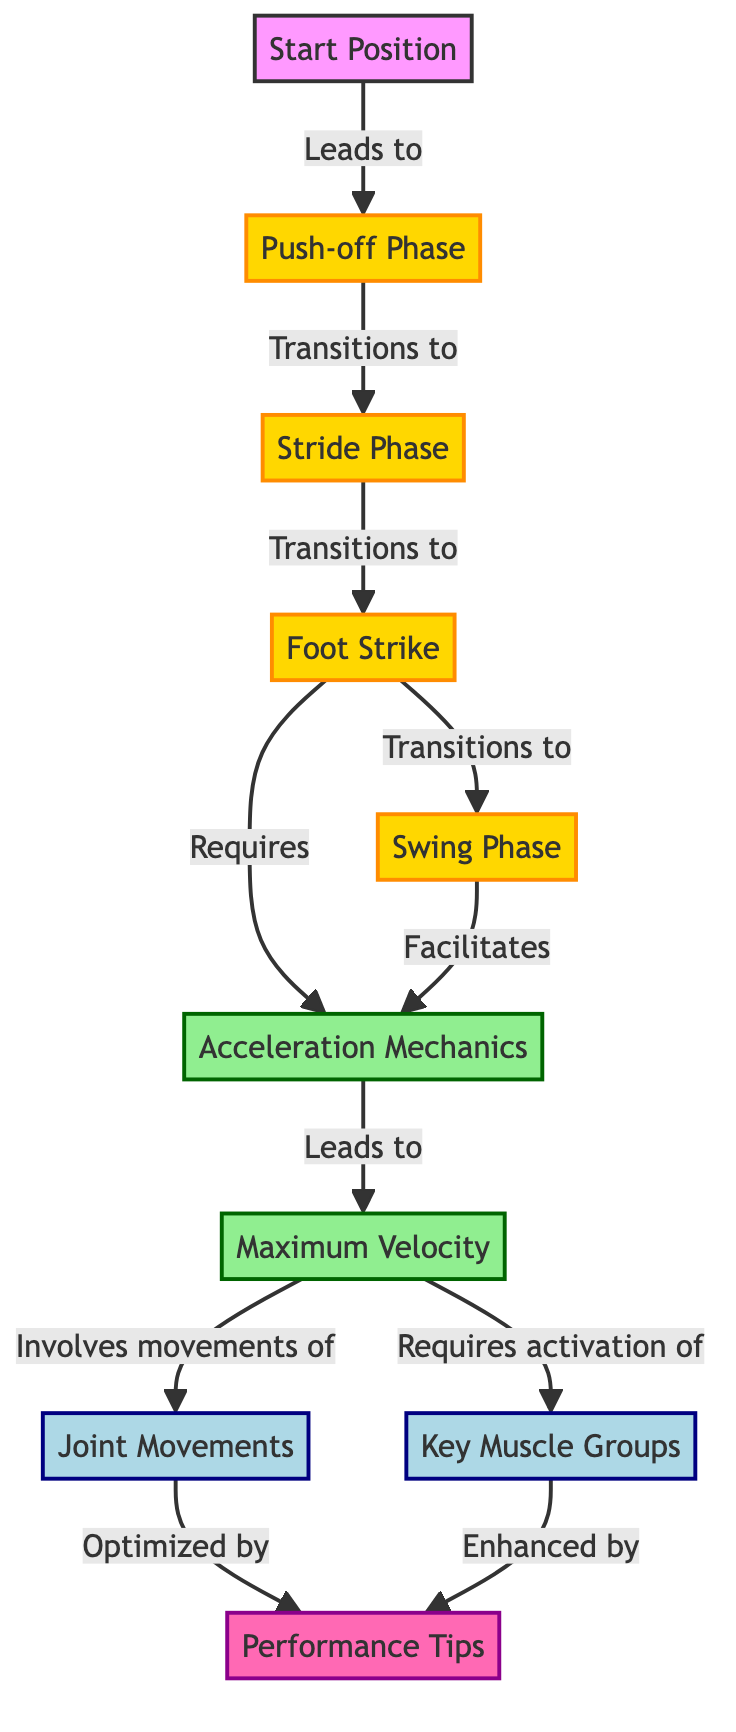What is the first phase of sprinting? The diagram starts with a node labeled "Start Position," which directly leads to the "Push-off Phase." Therefore, the first phase is identified as "Push-off Phase."
Answer: Push-off Phase What comes after the "Stride Phase"? According to the flow in the diagram, following the "Stride Phase" is the "Foot Strike." So, to determine what comes next, we refer to the connection between these two nodes, which shows the direct transition from "Stride Phase" to "Foot Strike."
Answer: Foot Strike How many phases are identified in the diagram? By counting the nodes labeled with "Phase," we identify four phases in total: "Push-off Phase," "Stride Phase," "Foot Strike," and "Swing Phase." Thus, the total number of phases is determined to be four.
Answer: 4 What mechanics does the "Foot Strike" require? The diagram specifies that the "Foot Strike" phase requires "Acceleration Mechanics." Thus, this connection between "Foot Strike" and "Acceleration Mechanics" clearly indicates the requirement.
Answer: Acceleration Mechanics How does "Swing Phase" contribute to speed? The diagram indicates that the "Swing Phase" facilitates "Acceleration," showing a direct connection. Therefore, the "Swing Phase" plays a significant role in enhancing the speed of sprinting by aiding this acceleration.
Answer: Acceleration Which muscle activation is necessary for "Maximum Velocity"? The diagram shows that reaching "Maximum Velocity" involves activation of "Key Muscle Groups." This indicates that certain muscle groups are specifically required to attain this maximum speed.
Answer: Key Muscle Groups What role do performance tips play in the sprinting process? The diagram indicates that both "Joint Movements" and "Key Muscle Groups" are optimized and enhanced by the "Performance Tips" node. This indicates that tips can improve both muscular activation and joint mechanics in sprinting.
Answer: Optimized and Enhanced What is the final outcome of the sprinting process as per the diagram? The diagram leads to the "Maximum Velocity" node at the end of the process. All earlier phases and mechanics ultimately aim to achieve this state of maximum speed in sprinting.
Answer: Maximum Velocity 